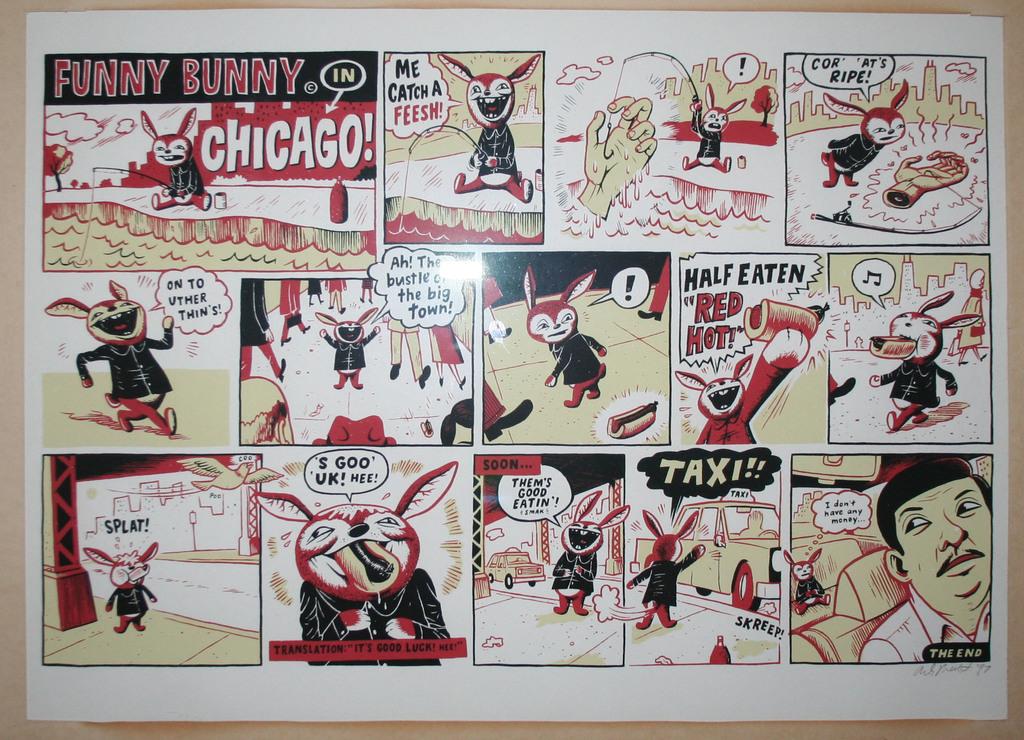What city name is under funny bunny?
Provide a succinct answer. Chicago. What is the text in the second to last scene?
Make the answer very short. Taxi. 